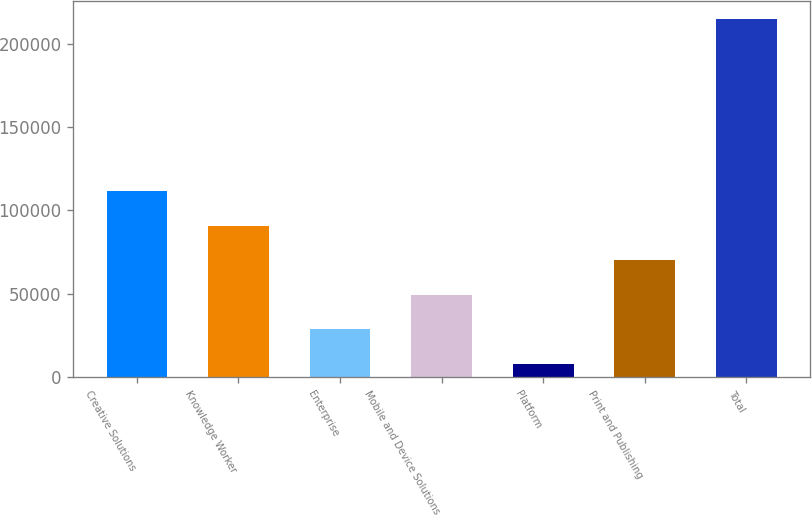Convert chart to OTSL. <chart><loc_0><loc_0><loc_500><loc_500><bar_chart><fcel>Creative Solutions<fcel>Knowledge Worker<fcel>Enterprise<fcel>Mobile and Device Solutions<fcel>Platform<fcel>Print and Publishing<fcel>Total<nl><fcel>111402<fcel>90690.4<fcel>28555.6<fcel>49267.2<fcel>7844<fcel>69978.8<fcel>214960<nl></chart> 